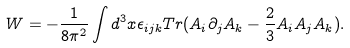Convert formula to latex. <formula><loc_0><loc_0><loc_500><loc_500>W = - \frac { 1 } { 8 \pi ^ { 2 } } \int d ^ { 3 } x \epsilon _ { i j k } T r ( A _ { i } \partial _ { j } A _ { k } - \frac { 2 } { 3 } A _ { i } A _ { j } A _ { k } ) .</formula> 